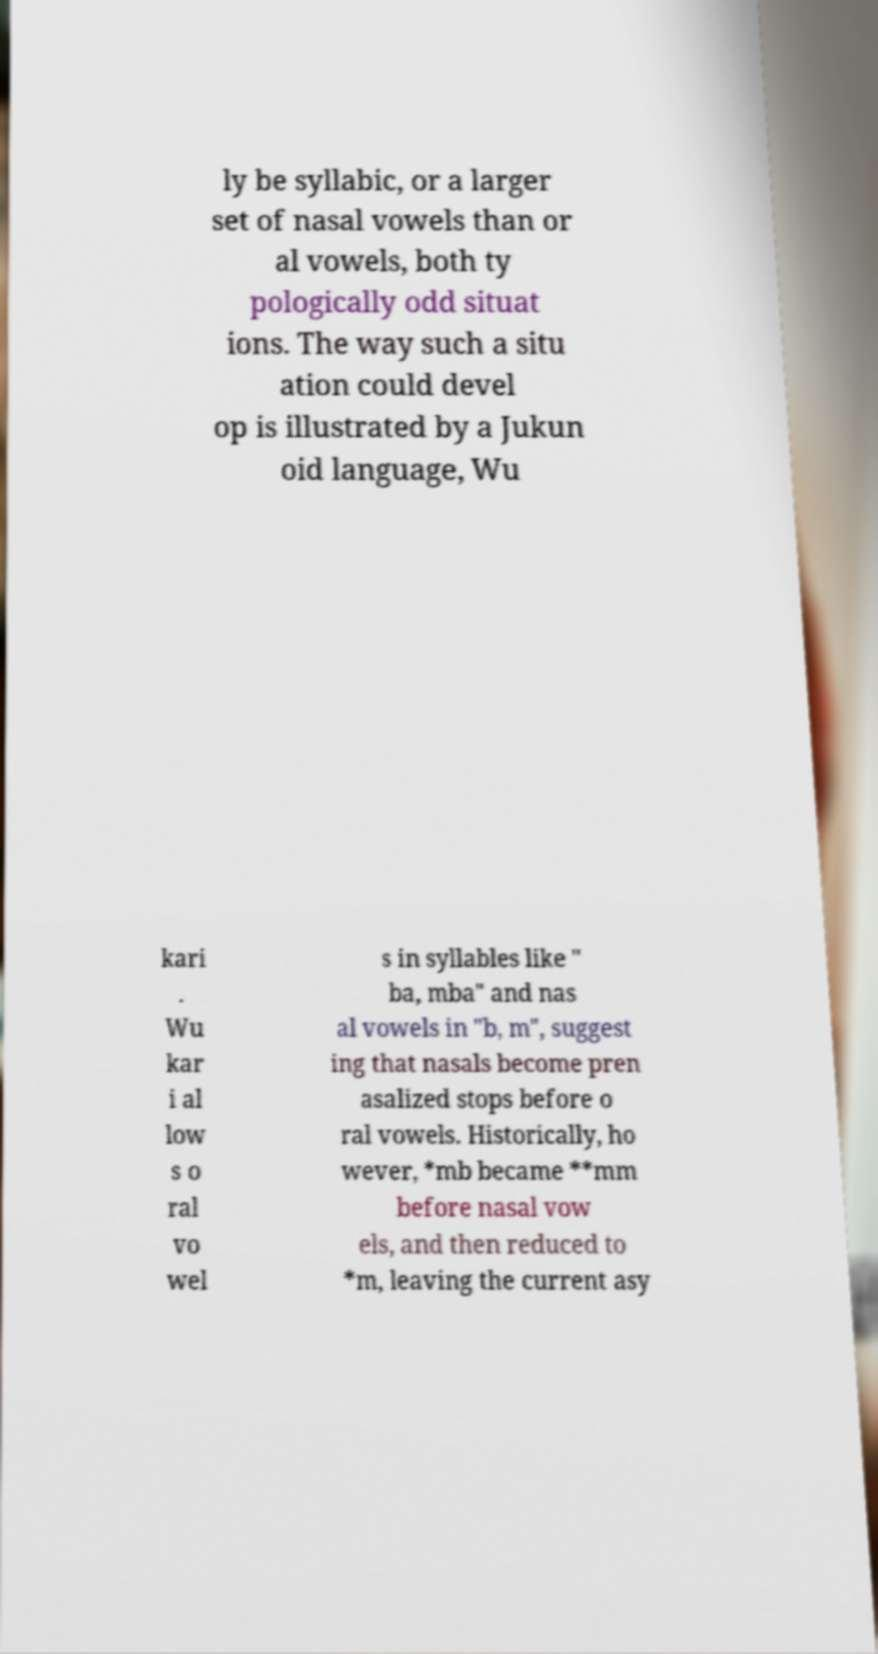I need the written content from this picture converted into text. Can you do that? ly be syllabic, or a larger set of nasal vowels than or al vowels, both ty pologically odd situat ions. The way such a situ ation could devel op is illustrated by a Jukun oid language, Wu kari . Wu kar i al low s o ral vo wel s in syllables like " ba, mba" and nas al vowels in "b, m", suggest ing that nasals become pren asalized stops before o ral vowels. Historically, ho wever, *mb became **mm before nasal vow els, and then reduced to *m, leaving the current asy 